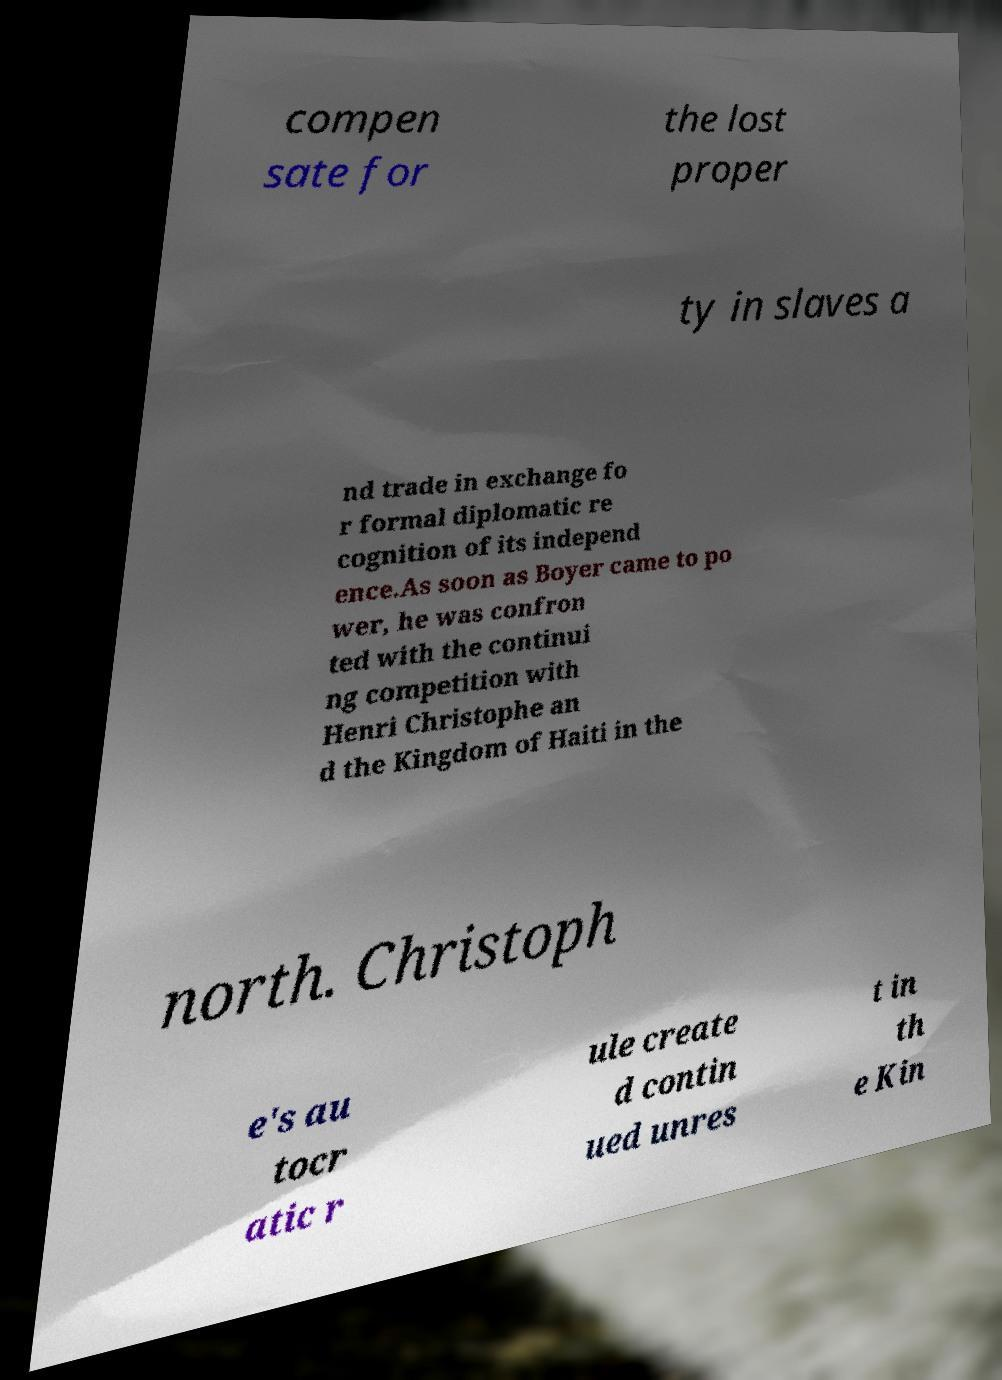Could you assist in decoding the text presented in this image and type it out clearly? compen sate for the lost proper ty in slaves a nd trade in exchange fo r formal diplomatic re cognition of its independ ence.As soon as Boyer came to po wer, he was confron ted with the continui ng competition with Henri Christophe an d the Kingdom of Haiti in the north. Christoph e's au tocr atic r ule create d contin ued unres t in th e Kin 